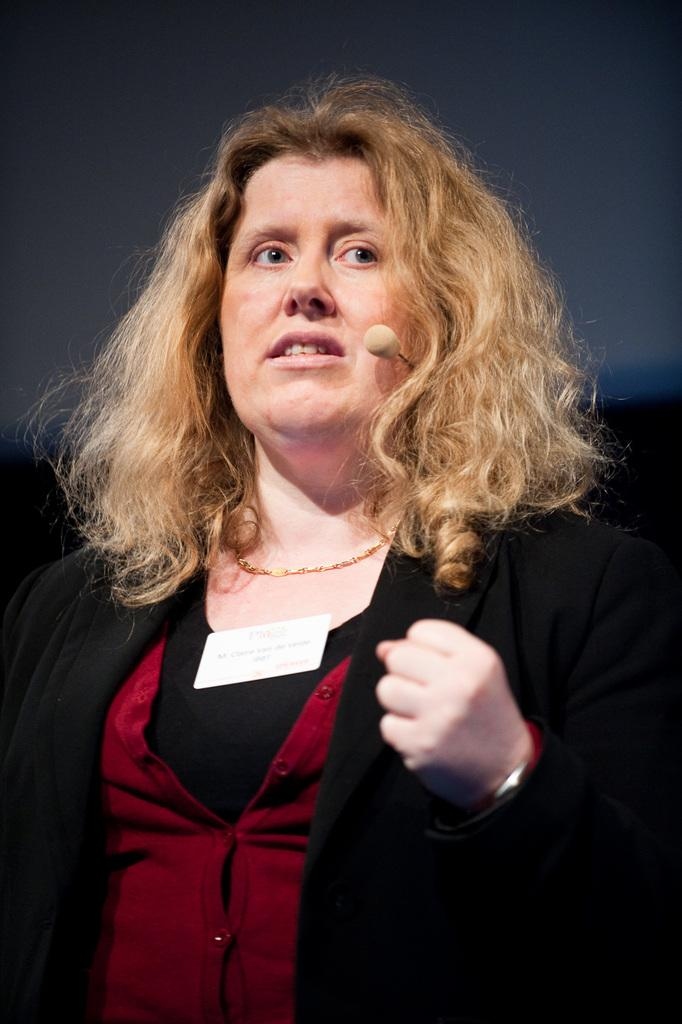Who is the main subject in the image? There is a lady in the image. What is the lady wearing? The lady is wearing a black suit. Can you describe the background of the image? The background of the image is not clear. What type of unit can be seen in the image? There is no unit present in the image; it features a lady wearing a black suit. What scent is associated with the lady in the image? There is no information about the scent of the lady or any objects in the image. 